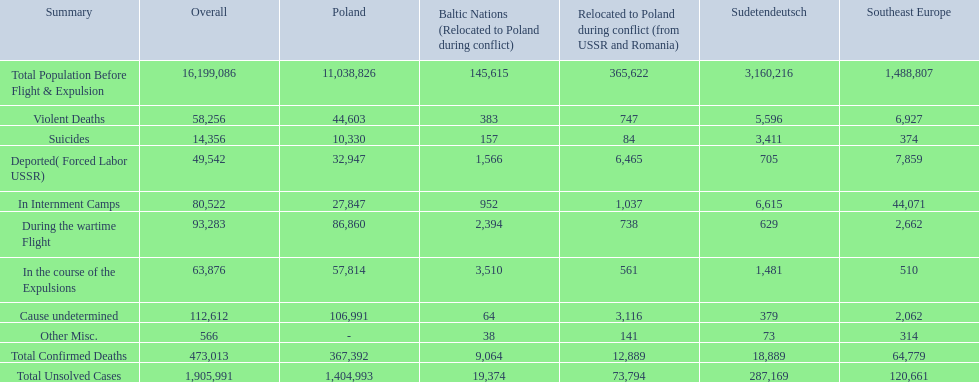What was the cause of the most deaths? Cause undetermined. 